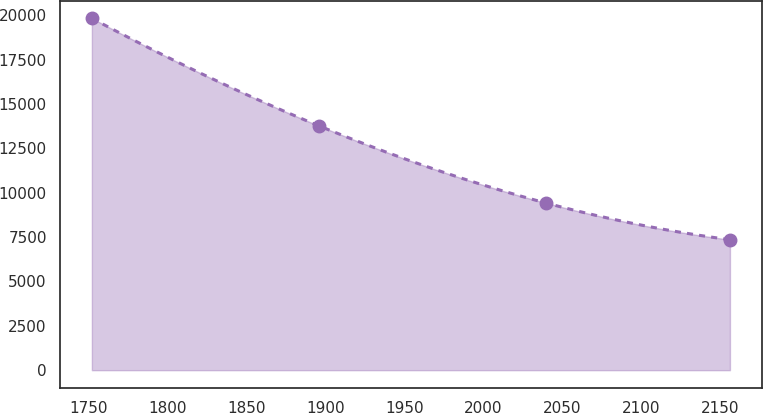Convert chart to OTSL. <chart><loc_0><loc_0><loc_500><loc_500><line_chart><ecel><fcel>Unnamed: 1<nl><fcel>1752.09<fcel>19829.5<nl><fcel>1895.87<fcel>13769<nl><fcel>2039.68<fcel>9418.94<nl><fcel>2156.06<fcel>7353.88<nl></chart> 